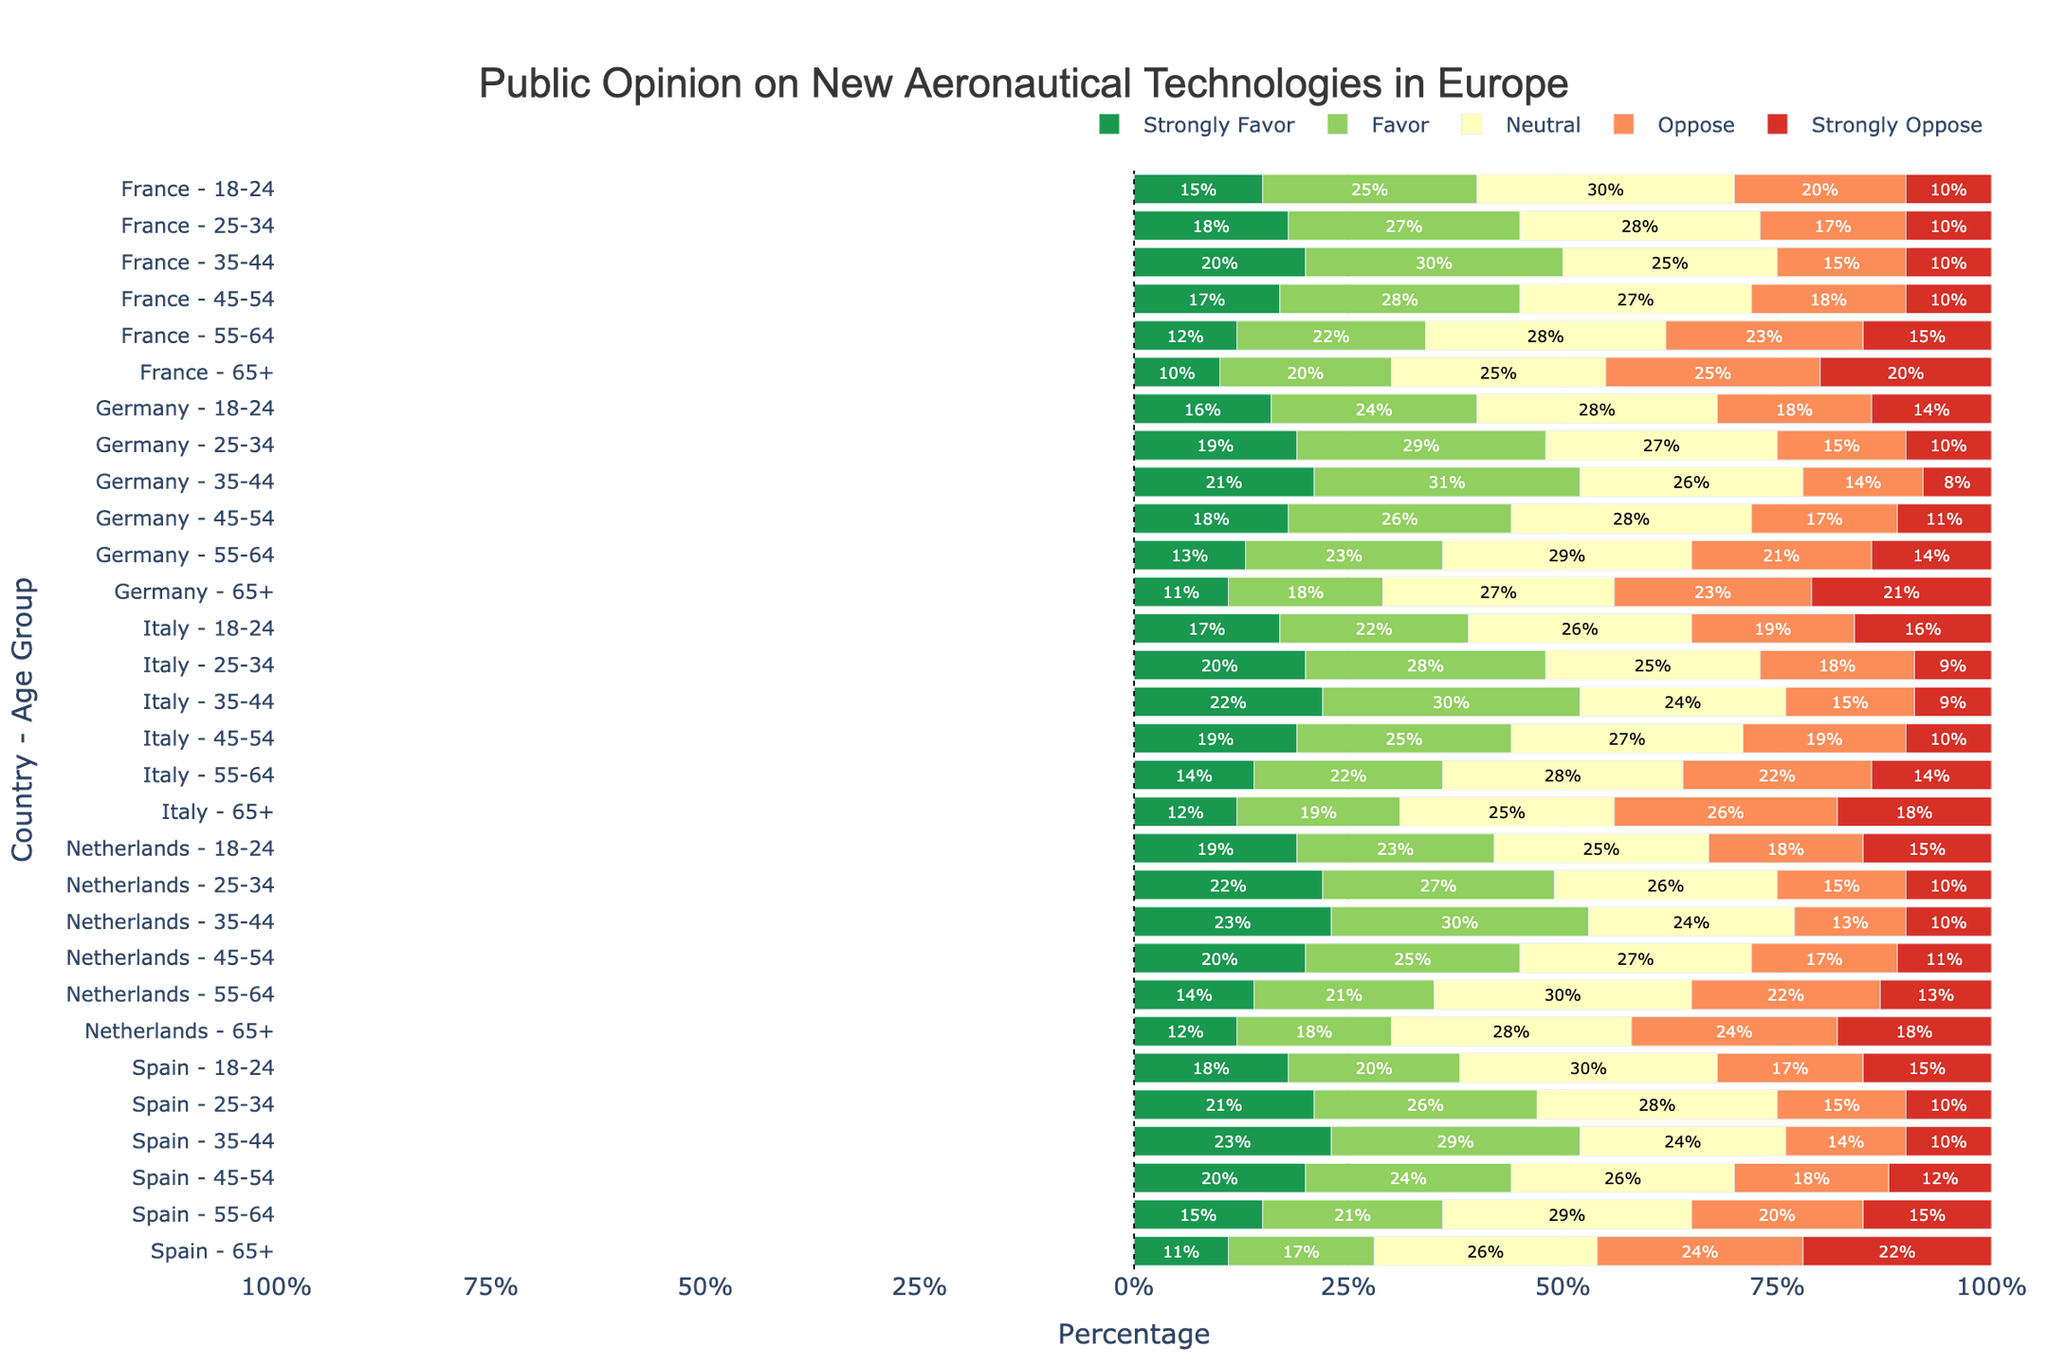What is the average percentage of people in France aged 18-24 who strongly favor or favor new aeronautical technologies? To find the answer, sum the percentages of "Strongly Favor" and "Favor" for France aged 18-24 (15 + 25 = 40) and then divide by 2 to get the average: 40/2 = 20
Answer: 20% Which age group in Germany shows the most opposition (sum of "Oppose" and "Strongly Oppose") to new aeronautical technologies? For each age group in Germany, add the percentages of "Oppose" and "Strongly Oppose". Compare the sums:
18-24: 18 + 14 = 32
25-34: 15 + 10 = 25
35-44: 14 + 8 = 22
45-54: 17 + 11 = 28
55-64: 21 + 14 = 35
65+: 23 + 21 = 44
The age group 65+ has the highest total opposition with 44%
Answer: 65+ How do the 35-44 age groups in Italy and Spain compare in terms of neutral opinions? Look at the "Neutral" percentages for the 35-44 age group in both countries. Italy has 24% neutral, and Spain has 24% as well. Both have the same percentage.
Answer: Equal What is the combined percentage of people in the Netherlands aged 55-64 who are either neutral or oppose the new technologies? Add up the percentages of "Neutral" (30), "Oppose" (22), and "Strongly Oppose" (13) for the 55-64 age group in the Netherlands: 30 + 22 + 13 = 65
Answer: 65% Which country and age group has the highest percentage of neutral opinions overall? Find the highest "Neutral" percentage across all countries and age groups. The highest neutral percentage is 30% found in the France 18-24, Spain 18-24, and Netherlands 55-64 groups. Therefore, the answer can be any one of these.
Answer: France 18-24 or Spain 18-24 or Netherlands 55-64 What is the difference in the percentage of people who strongly favor new aeronautical technologies between the 18-24 group in Spain and the 65+ group in Italy? Subtract the percentage of "Strongly Favor" for the 65+ group in Italy (12%) from that for the 18-24 group in Spain (18%): 18 - 12 = 6
Answer: 6 Which country has the most favorable opinion (sum of "Strongly Favor" and "Favor") among those aged 25-34? Add the percentages of "Strongly Favor" and "Favor" for each country in the 25-34 age group. Compare the sums:
France: 18 + 27 = 45
Germany: 19 + 29 = 48
Italy: 20 + 28 = 48
Spain: 21 + 26 = 47
Netherlands: 22 + 27 = 49
The Netherlands has the highest total favorable opinion with 49%
Answer: Netherlands For the age group 45-54 in France and Italy, which has the greater percentage difference between those who favor and those who oppose the technologies? For the 45-54 age group:
France: Favor = 28, Oppose = 18, Difference = 28 - 18 = 10
Italy: Favor = 25, Oppose = 19, Difference = 25 - 19 = 6
France has a greater percentage difference with 10%
Answer: France What proportion of the 65+ group in Germany opposes (sum of "Oppose" and "Strongly Oppose") new technologies? Sum the percentages of "Oppose" and "Strongly Oppose" for the 65+ group in Germany: 23 + 21 = 44%. This means 44% of the 65+ group in Germany opposes new technologies.
Answer: 44% How does the 25-34 age group in Germany compare to the 25-34 age group in the Netherlands in terms of strong opposition? Compare the "Strongly Oppose" percentages: Germany 25-34 has 10%, while Netherlands 25-34 has 10%. Both have the same percentage.
Answer: Equal 